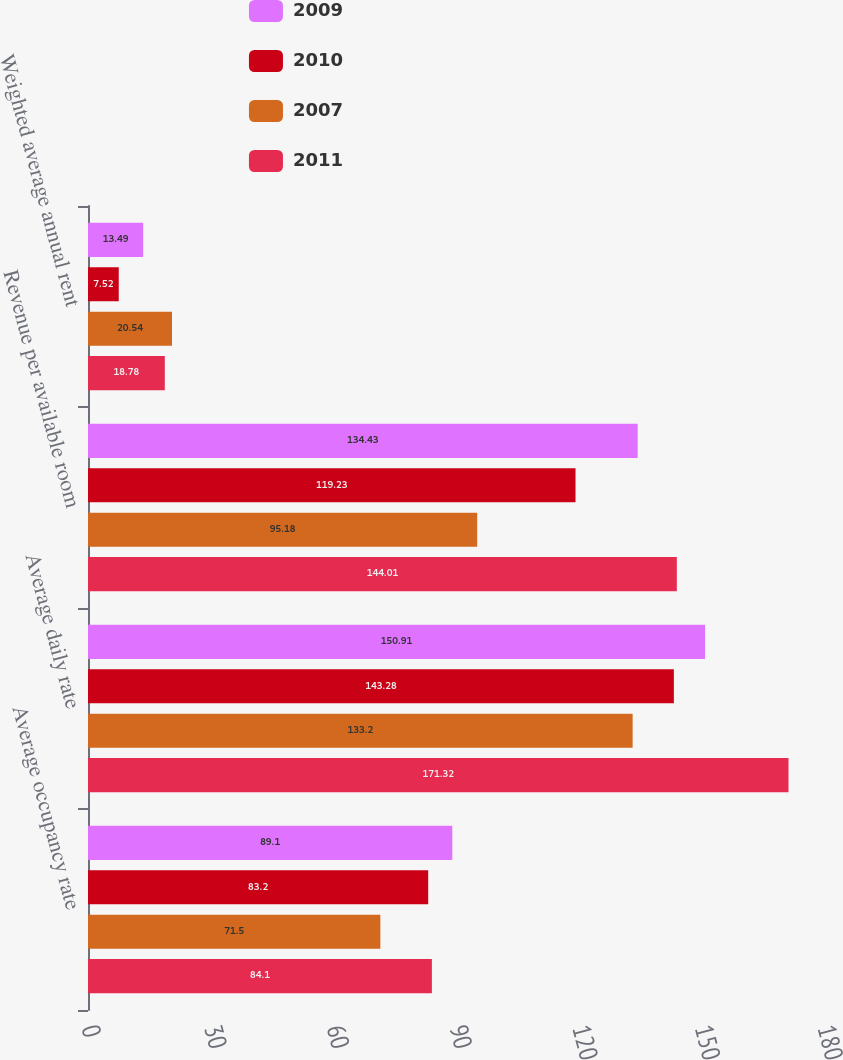Convert chart. <chart><loc_0><loc_0><loc_500><loc_500><stacked_bar_chart><ecel><fcel>Average occupancy rate<fcel>Average daily rate<fcel>Revenue per available room<fcel>Weighted average annual rent<nl><fcel>2009<fcel>89.1<fcel>150.91<fcel>134.43<fcel>13.49<nl><fcel>2010<fcel>83.2<fcel>143.28<fcel>119.23<fcel>7.52<nl><fcel>2007<fcel>71.5<fcel>133.2<fcel>95.18<fcel>20.54<nl><fcel>2011<fcel>84.1<fcel>171.32<fcel>144.01<fcel>18.78<nl></chart> 